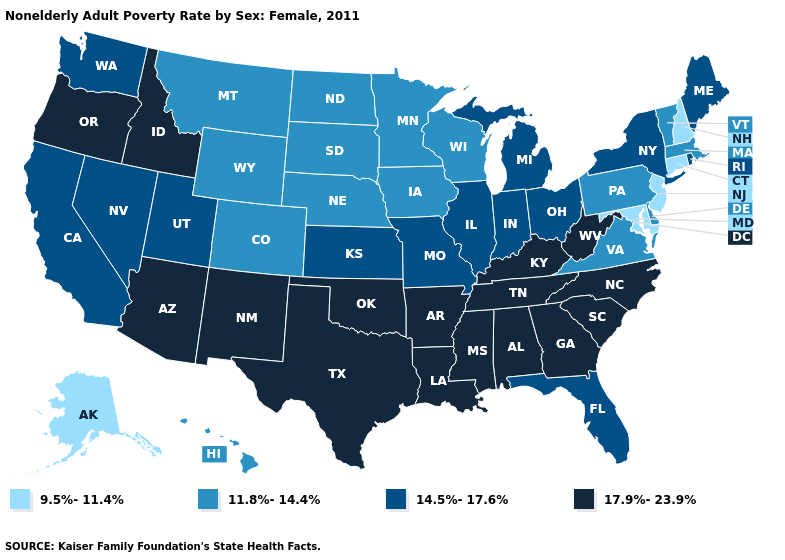Name the states that have a value in the range 14.5%-17.6%?
Concise answer only. California, Florida, Illinois, Indiana, Kansas, Maine, Michigan, Missouri, Nevada, New York, Ohio, Rhode Island, Utah, Washington. Does the first symbol in the legend represent the smallest category?
Keep it brief. Yes. Name the states that have a value in the range 9.5%-11.4%?
Keep it brief. Alaska, Connecticut, Maryland, New Hampshire, New Jersey. What is the value of Arkansas?
Concise answer only. 17.9%-23.9%. How many symbols are there in the legend?
Answer briefly. 4. Name the states that have a value in the range 11.8%-14.4%?
Concise answer only. Colorado, Delaware, Hawaii, Iowa, Massachusetts, Minnesota, Montana, Nebraska, North Dakota, Pennsylvania, South Dakota, Vermont, Virginia, Wisconsin, Wyoming. Among the states that border Oregon , which have the lowest value?
Quick response, please. California, Nevada, Washington. Is the legend a continuous bar?
Concise answer only. No. What is the value of Tennessee?
Keep it brief. 17.9%-23.9%. Among the states that border Nevada , which have the highest value?
Keep it brief. Arizona, Idaho, Oregon. Name the states that have a value in the range 9.5%-11.4%?
Concise answer only. Alaska, Connecticut, Maryland, New Hampshire, New Jersey. What is the value of Mississippi?
Concise answer only. 17.9%-23.9%. Among the states that border Michigan , does Indiana have the lowest value?
Short answer required. No. Does New Hampshire have the highest value in the Northeast?
Answer briefly. No. What is the value of Kentucky?
Concise answer only. 17.9%-23.9%. 